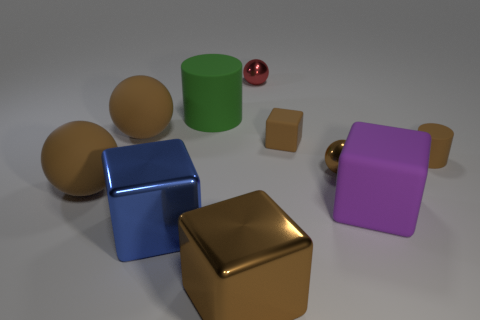Subtract all tiny rubber cubes. How many cubes are left? 3 Subtract 2 cubes. How many cubes are left? 2 Subtract all green cylinders. How many brown cubes are left? 2 Subtract all blue cubes. How many cubes are left? 3 Subtract all blocks. How many objects are left? 6 Subtract all gray spheres. Subtract all blue cylinders. How many spheres are left? 4 Subtract all brown balls. Subtract all brown metallic things. How many objects are left? 5 Add 6 spheres. How many spheres are left? 10 Add 9 yellow blocks. How many yellow blocks exist? 9 Subtract 1 green cylinders. How many objects are left? 9 